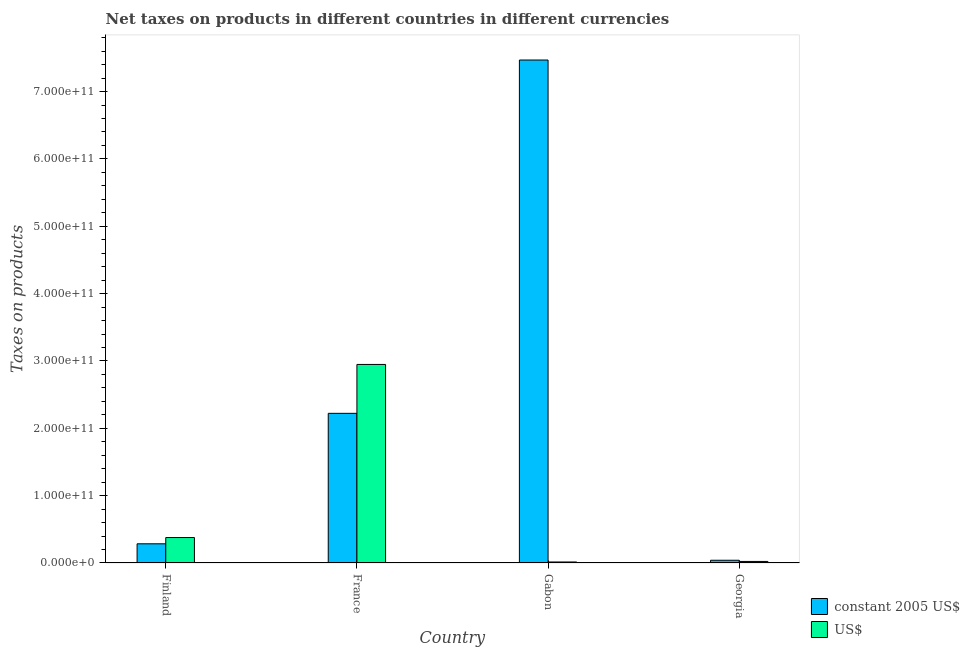How many different coloured bars are there?
Provide a succinct answer. 2. Are the number of bars on each tick of the X-axis equal?
Make the answer very short. Yes. How many bars are there on the 1st tick from the left?
Ensure brevity in your answer.  2. How many bars are there on the 3rd tick from the right?
Your response must be concise. 2. What is the label of the 4th group of bars from the left?
Offer a terse response. Georgia. In how many cases, is the number of bars for a given country not equal to the number of legend labels?
Ensure brevity in your answer.  0. What is the net taxes in constant 2005 us$ in Finland?
Make the answer very short. 2.85e+1. Across all countries, what is the maximum net taxes in us$?
Ensure brevity in your answer.  2.95e+11. Across all countries, what is the minimum net taxes in constant 2005 us$?
Give a very brief answer. 4.05e+09. In which country was the net taxes in constant 2005 us$ maximum?
Your answer should be compact. Gabon. In which country was the net taxes in us$ minimum?
Offer a very short reply. Gabon. What is the total net taxes in constant 2005 us$ in the graph?
Give a very brief answer. 1.00e+12. What is the difference between the net taxes in us$ in Finland and that in France?
Ensure brevity in your answer.  -2.57e+11. What is the difference between the net taxes in constant 2005 us$ in Gabon and the net taxes in us$ in France?
Offer a very short reply. 4.52e+11. What is the average net taxes in us$ per country?
Offer a very short reply. 8.41e+1. What is the difference between the net taxes in us$ and net taxes in constant 2005 us$ in France?
Provide a succinct answer. 7.26e+1. What is the ratio of the net taxes in us$ in France to that in Georgia?
Ensure brevity in your answer.  128.38. What is the difference between the highest and the second highest net taxes in constant 2005 us$?
Offer a terse response. 5.25e+11. What is the difference between the highest and the lowest net taxes in constant 2005 us$?
Make the answer very short. 7.43e+11. Is the sum of the net taxes in us$ in Gabon and Georgia greater than the maximum net taxes in constant 2005 us$ across all countries?
Keep it short and to the point. No. What does the 2nd bar from the left in Gabon represents?
Your answer should be very brief. US$. What does the 1st bar from the right in France represents?
Keep it short and to the point. US$. How many bars are there?
Your answer should be very brief. 8. Are all the bars in the graph horizontal?
Ensure brevity in your answer.  No. How many countries are there in the graph?
Your response must be concise. 4. What is the difference between two consecutive major ticks on the Y-axis?
Keep it short and to the point. 1.00e+11. Does the graph contain any zero values?
Your answer should be very brief. No. Does the graph contain grids?
Offer a very short reply. No. What is the title of the graph?
Ensure brevity in your answer.  Net taxes on products in different countries in different currencies. Does "Fraud firms" appear as one of the legend labels in the graph?
Ensure brevity in your answer.  No. What is the label or title of the Y-axis?
Keep it short and to the point. Taxes on products. What is the Taxes on products of constant 2005 US$ in Finland?
Give a very brief answer. 2.85e+1. What is the Taxes on products in US$ in Finland?
Your response must be concise. 3.78e+1. What is the Taxes on products of constant 2005 US$ in France?
Your answer should be compact. 2.22e+11. What is the Taxes on products of US$ in France?
Provide a short and direct response. 2.95e+11. What is the Taxes on products of constant 2005 US$ in Gabon?
Your response must be concise. 7.47e+11. What is the Taxes on products of US$ in Gabon?
Make the answer very short. 1.51e+09. What is the Taxes on products of constant 2005 US$ in Georgia?
Provide a succinct answer. 4.05e+09. What is the Taxes on products in US$ in Georgia?
Ensure brevity in your answer.  2.30e+09. Across all countries, what is the maximum Taxes on products in constant 2005 US$?
Your response must be concise. 7.47e+11. Across all countries, what is the maximum Taxes on products of US$?
Offer a very short reply. 2.95e+11. Across all countries, what is the minimum Taxes on products in constant 2005 US$?
Offer a terse response. 4.05e+09. Across all countries, what is the minimum Taxes on products of US$?
Offer a very short reply. 1.51e+09. What is the total Taxes on products of constant 2005 US$ in the graph?
Provide a short and direct response. 1.00e+12. What is the total Taxes on products of US$ in the graph?
Your answer should be very brief. 3.36e+11. What is the difference between the Taxes on products of constant 2005 US$ in Finland and that in France?
Your response must be concise. -1.94e+11. What is the difference between the Taxes on products in US$ in Finland and that in France?
Offer a very short reply. -2.57e+11. What is the difference between the Taxes on products in constant 2005 US$ in Finland and that in Gabon?
Offer a terse response. -7.18e+11. What is the difference between the Taxes on products in US$ in Finland and that in Gabon?
Your answer should be very brief. 3.63e+1. What is the difference between the Taxes on products of constant 2005 US$ in Finland and that in Georgia?
Make the answer very short. 2.44e+1. What is the difference between the Taxes on products in US$ in Finland and that in Georgia?
Give a very brief answer. 3.55e+1. What is the difference between the Taxes on products of constant 2005 US$ in France and that in Gabon?
Provide a succinct answer. -5.25e+11. What is the difference between the Taxes on products of US$ in France and that in Gabon?
Provide a succinct answer. 2.93e+11. What is the difference between the Taxes on products of constant 2005 US$ in France and that in Georgia?
Give a very brief answer. 2.18e+11. What is the difference between the Taxes on products of US$ in France and that in Georgia?
Ensure brevity in your answer.  2.93e+11. What is the difference between the Taxes on products in constant 2005 US$ in Gabon and that in Georgia?
Keep it short and to the point. 7.43e+11. What is the difference between the Taxes on products in US$ in Gabon and that in Georgia?
Provide a succinct answer. -7.86e+08. What is the difference between the Taxes on products in constant 2005 US$ in Finland and the Taxes on products in US$ in France?
Your answer should be very brief. -2.66e+11. What is the difference between the Taxes on products in constant 2005 US$ in Finland and the Taxes on products in US$ in Gabon?
Give a very brief answer. 2.70e+1. What is the difference between the Taxes on products of constant 2005 US$ in Finland and the Taxes on products of US$ in Georgia?
Make the answer very short. 2.62e+1. What is the difference between the Taxes on products of constant 2005 US$ in France and the Taxes on products of US$ in Gabon?
Offer a very short reply. 2.21e+11. What is the difference between the Taxes on products in constant 2005 US$ in France and the Taxes on products in US$ in Georgia?
Offer a terse response. 2.20e+11. What is the difference between the Taxes on products of constant 2005 US$ in Gabon and the Taxes on products of US$ in Georgia?
Ensure brevity in your answer.  7.45e+11. What is the average Taxes on products of constant 2005 US$ per country?
Offer a very short reply. 2.50e+11. What is the average Taxes on products in US$ per country?
Ensure brevity in your answer.  8.41e+1. What is the difference between the Taxes on products of constant 2005 US$ and Taxes on products of US$ in Finland?
Offer a terse response. -9.31e+09. What is the difference between the Taxes on products in constant 2005 US$ and Taxes on products in US$ in France?
Ensure brevity in your answer.  -7.26e+1. What is the difference between the Taxes on products in constant 2005 US$ and Taxes on products in US$ in Gabon?
Offer a very short reply. 7.45e+11. What is the difference between the Taxes on products in constant 2005 US$ and Taxes on products in US$ in Georgia?
Make the answer very short. 1.76e+09. What is the ratio of the Taxes on products in constant 2005 US$ in Finland to that in France?
Your answer should be very brief. 0.13. What is the ratio of the Taxes on products of US$ in Finland to that in France?
Give a very brief answer. 0.13. What is the ratio of the Taxes on products in constant 2005 US$ in Finland to that in Gabon?
Provide a short and direct response. 0.04. What is the ratio of the Taxes on products of US$ in Finland to that in Gabon?
Offer a very short reply. 25.02. What is the ratio of the Taxes on products in constant 2005 US$ in Finland to that in Georgia?
Offer a very short reply. 7.03. What is the ratio of the Taxes on products of US$ in Finland to that in Georgia?
Your response must be concise. 16.46. What is the ratio of the Taxes on products in constant 2005 US$ in France to that in Gabon?
Provide a succinct answer. 0.3. What is the ratio of the Taxes on products in US$ in France to that in Gabon?
Your answer should be very brief. 195.17. What is the ratio of the Taxes on products of constant 2005 US$ in France to that in Georgia?
Provide a short and direct response. 54.8. What is the ratio of the Taxes on products in US$ in France to that in Georgia?
Keep it short and to the point. 128.38. What is the ratio of the Taxes on products of constant 2005 US$ in Gabon to that in Georgia?
Your answer should be very brief. 184.19. What is the ratio of the Taxes on products of US$ in Gabon to that in Georgia?
Provide a succinct answer. 0.66. What is the difference between the highest and the second highest Taxes on products of constant 2005 US$?
Your answer should be compact. 5.25e+11. What is the difference between the highest and the second highest Taxes on products in US$?
Your response must be concise. 2.57e+11. What is the difference between the highest and the lowest Taxes on products of constant 2005 US$?
Make the answer very short. 7.43e+11. What is the difference between the highest and the lowest Taxes on products of US$?
Keep it short and to the point. 2.93e+11. 